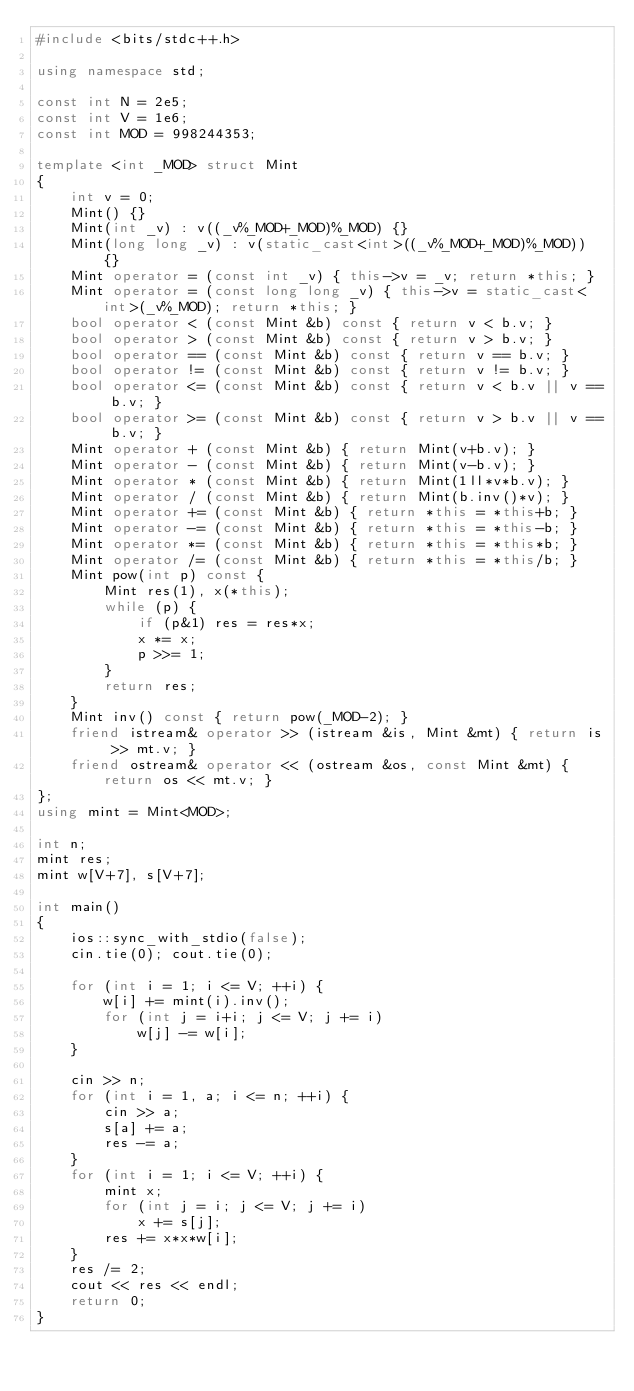Convert code to text. <code><loc_0><loc_0><loc_500><loc_500><_C++_>#include <bits/stdc++.h>

using namespace std;

const int N = 2e5;
const int V = 1e6;
const int MOD = 998244353;

template <int _MOD> struct Mint
{
    int v = 0;
    Mint() {}
    Mint(int _v) : v((_v%_MOD+_MOD)%_MOD) {}
    Mint(long long _v) : v(static_cast<int>((_v%_MOD+_MOD)%_MOD)) {}
    Mint operator = (const int _v) { this->v = _v; return *this; }
    Mint operator = (const long long _v) { this->v = static_cast<int>(_v%_MOD); return *this; }
    bool operator < (const Mint &b) const { return v < b.v; }
    bool operator > (const Mint &b) const { return v > b.v; }
    bool operator == (const Mint &b) const { return v == b.v; }
    bool operator != (const Mint &b) const { return v != b.v; }
    bool operator <= (const Mint &b) const { return v < b.v || v == b.v; }
    bool operator >= (const Mint &b) const { return v > b.v || v == b.v; }
    Mint operator + (const Mint &b) { return Mint(v+b.v); }
    Mint operator - (const Mint &b) { return Mint(v-b.v); }
    Mint operator * (const Mint &b) { return Mint(1ll*v*b.v); }
    Mint operator / (const Mint &b) { return Mint(b.inv()*v); }
    Mint operator += (const Mint &b) { return *this = *this+b; }
    Mint operator -= (const Mint &b) { return *this = *this-b; }
    Mint operator *= (const Mint &b) { return *this = *this*b; }
    Mint operator /= (const Mint &b) { return *this = *this/b; }
    Mint pow(int p) const {
        Mint res(1), x(*this);
        while (p) {
            if (p&1) res = res*x;
            x *= x;
            p >>= 1;
        }
        return res;
    }
    Mint inv() const { return pow(_MOD-2); }
    friend istream& operator >> (istream &is, Mint &mt) { return is >> mt.v; }
    friend ostream& operator << (ostream &os, const Mint &mt) { return os << mt.v; }
};
using mint = Mint<MOD>;

int n;
mint res;
mint w[V+7], s[V+7];

int main()
{
    ios::sync_with_stdio(false);
    cin.tie(0); cout.tie(0);

    for (int i = 1; i <= V; ++i) {
        w[i] += mint(i).inv();
        for (int j = i+i; j <= V; j += i)
            w[j] -= w[i];
    }

    cin >> n;
    for (int i = 1, a; i <= n; ++i) {
        cin >> a;
        s[a] += a;
        res -= a;
    }
    for (int i = 1; i <= V; ++i) {
        mint x;
        for (int j = i; j <= V; j += i)
            x += s[j];
        res += x*x*w[i];
    }
    res /= 2;
    cout << res << endl;
    return 0;
}</code> 